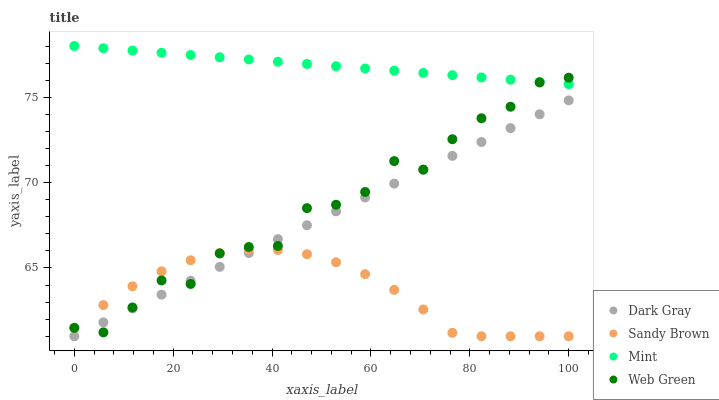Does Sandy Brown have the minimum area under the curve?
Answer yes or no. Yes. Does Mint have the maximum area under the curve?
Answer yes or no. Yes. Does Mint have the minimum area under the curve?
Answer yes or no. No. Does Sandy Brown have the maximum area under the curve?
Answer yes or no. No. Is Mint the smoothest?
Answer yes or no. Yes. Is Web Green the roughest?
Answer yes or no. Yes. Is Sandy Brown the smoothest?
Answer yes or no. No. Is Sandy Brown the roughest?
Answer yes or no. No. Does Dark Gray have the lowest value?
Answer yes or no. Yes. Does Mint have the lowest value?
Answer yes or no. No. Does Mint have the highest value?
Answer yes or no. Yes. Does Sandy Brown have the highest value?
Answer yes or no. No. Is Dark Gray less than Mint?
Answer yes or no. Yes. Is Mint greater than Sandy Brown?
Answer yes or no. Yes. Does Dark Gray intersect Sandy Brown?
Answer yes or no. Yes. Is Dark Gray less than Sandy Brown?
Answer yes or no. No. Is Dark Gray greater than Sandy Brown?
Answer yes or no. No. Does Dark Gray intersect Mint?
Answer yes or no. No. 